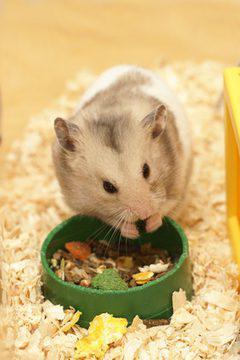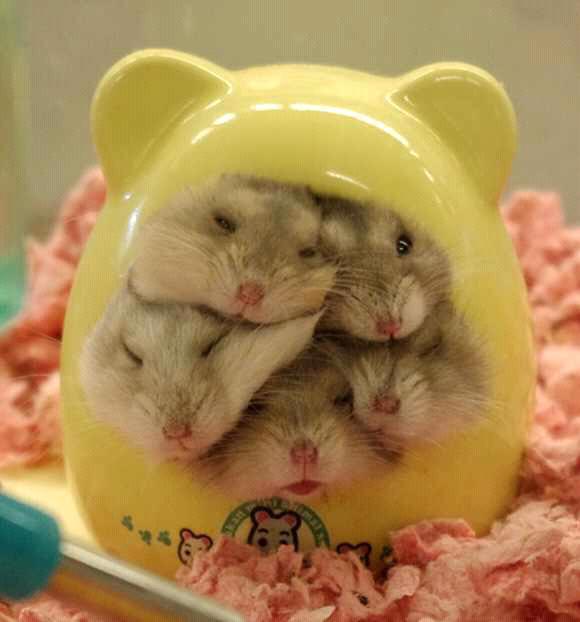The first image is the image on the left, the second image is the image on the right. Evaluate the accuracy of this statement regarding the images: "There are no more than 2 hamsters in the image pair". Is it true? Answer yes or no. No. The first image is the image on the left, the second image is the image on the right. Assess this claim about the two images: "There are no more than two mice eating out of a tray/bowl.". Correct or not? Answer yes or no. Yes. 